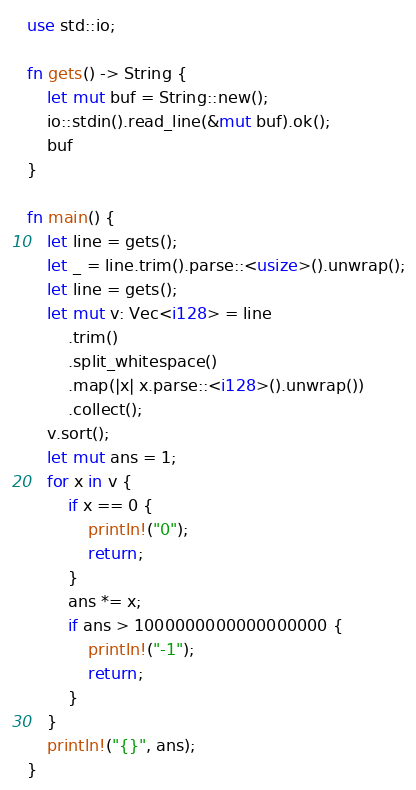Convert code to text. <code><loc_0><loc_0><loc_500><loc_500><_Rust_>use std::io;

fn gets() -> String {
    let mut buf = String::new();
    io::stdin().read_line(&mut buf).ok();
    buf
}

fn main() {
    let line = gets();
    let _ = line.trim().parse::<usize>().unwrap();
    let line = gets();
    let mut v: Vec<i128> = line
        .trim()
        .split_whitespace()
        .map(|x| x.parse::<i128>().unwrap())
        .collect();
    v.sort();
    let mut ans = 1;
    for x in v {
        if x == 0 {
            println!("0");
            return;
        }
        ans *= x;
        if ans > 1000000000000000000 {
            println!("-1");
            return;
        }
    }
    println!("{}", ans);
}
</code> 